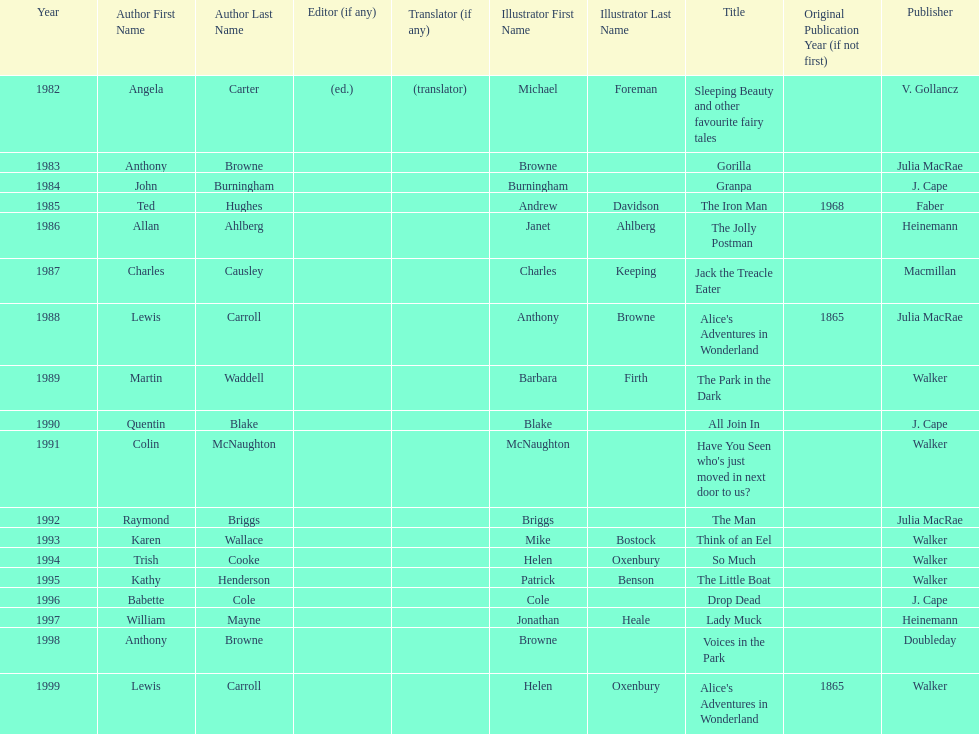What is the only title listed for 1999? Alice's Adventures in Wonderland. 